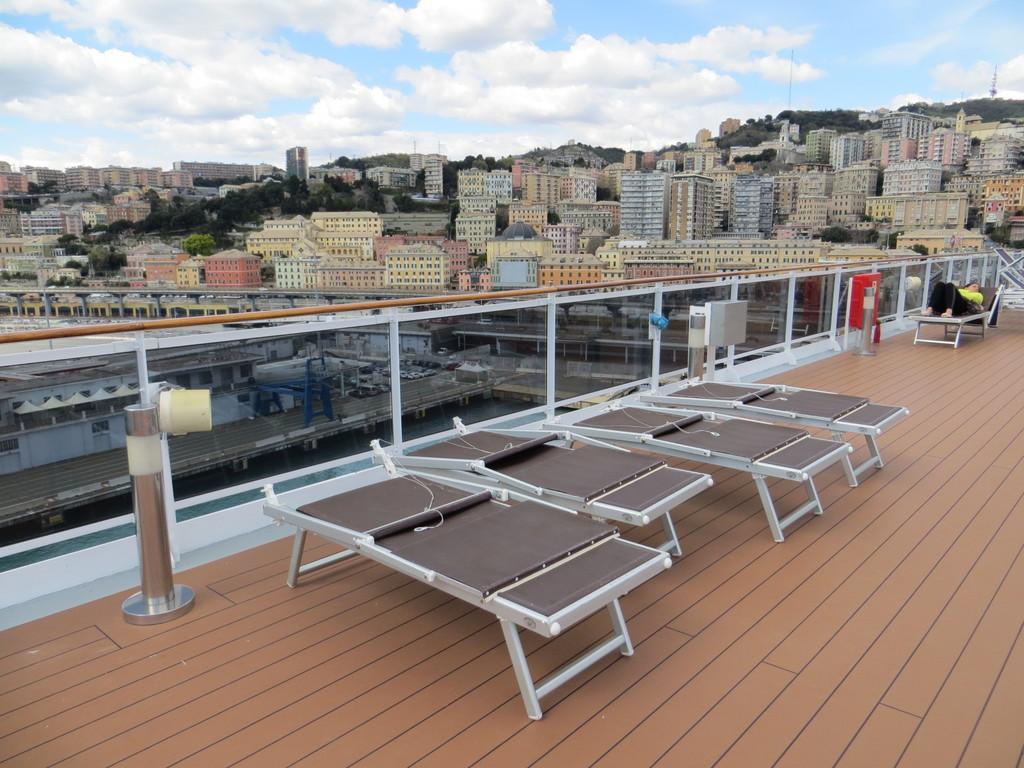Could you give a brief overview of what you see in this image? In the foreground of the picture we can see objects which are looking like benches, railing, person and floor. In the middle of the picture there are buildings, trees and other objects. At the top there is sky. 